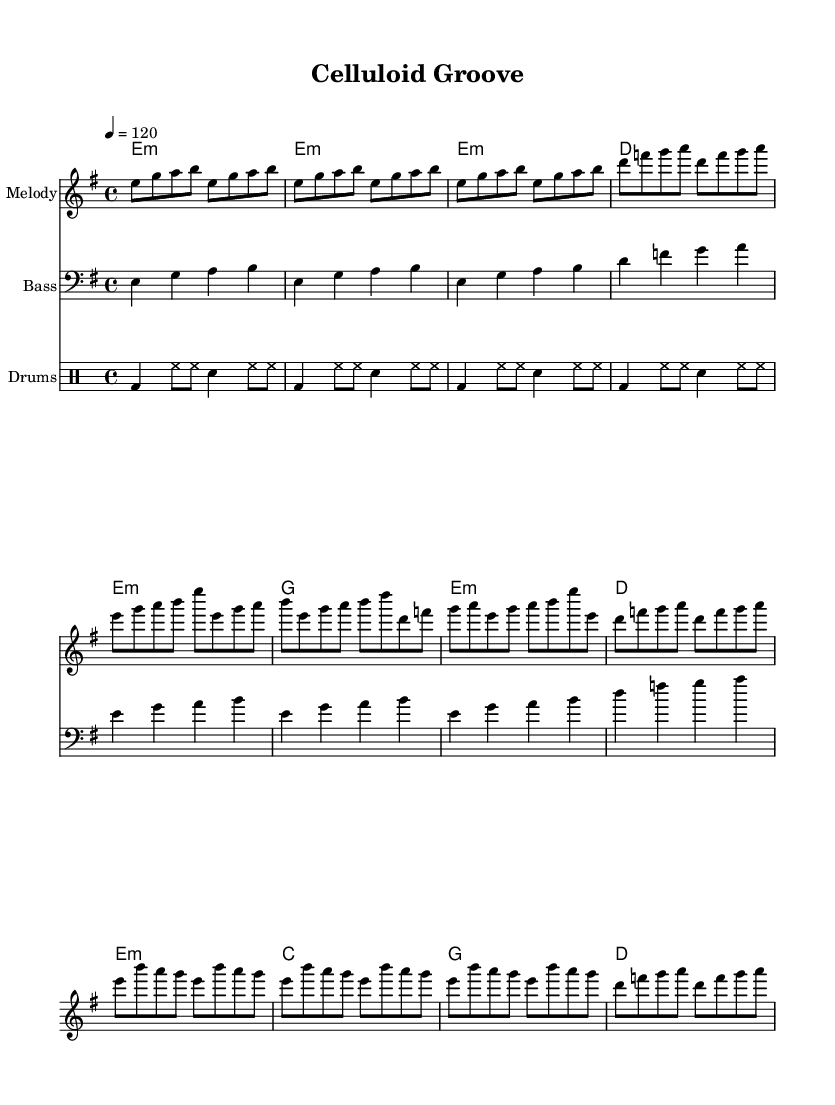What is the key signature of this music? The music is in E minor, which features one sharp (F#) in the key signature. This can be determined by looking at the key indicated at the beginning of the music.
Answer: E minor What is the time signature of the piece? The time signature is 4/4, meaning there are four beats in each measure, and the quarter note gets one beat. This is indicated at the beginning of the score.
Answer: 4/4 What is the tempo marking for this piece? The tempo marking is 120 beats per minute, as shown by the tempo indication at the start of the music. This indicates a moderate pace.
Answer: 120 What is the structure of the composition? The piece consists of an intro, verse, and chorus section. This can be deduced by the written layout of the music, where these sections are clearly defined and separated by measures.
Answer: Intro, Verse, Chorus How many measures are in the intro? The intro consists of four measures, which can be counted directly from the sheet music where the first section is marked.
Answer: 4 Which instruments are included in this score? The score includes melody, bass, and drums. This is indicated at the beginning of each staff, where the instrument names are listed.
Answer: Melody, Bass, Drums What type of rhythm is featured prominently in the drums? The drums feature a basic funk pattern, characterized by the kick and snare placements along with hi-hat usage typical in funk music. This can be identified by observing the rhythmic patterns on the drum staff.
Answer: Funk pattern 